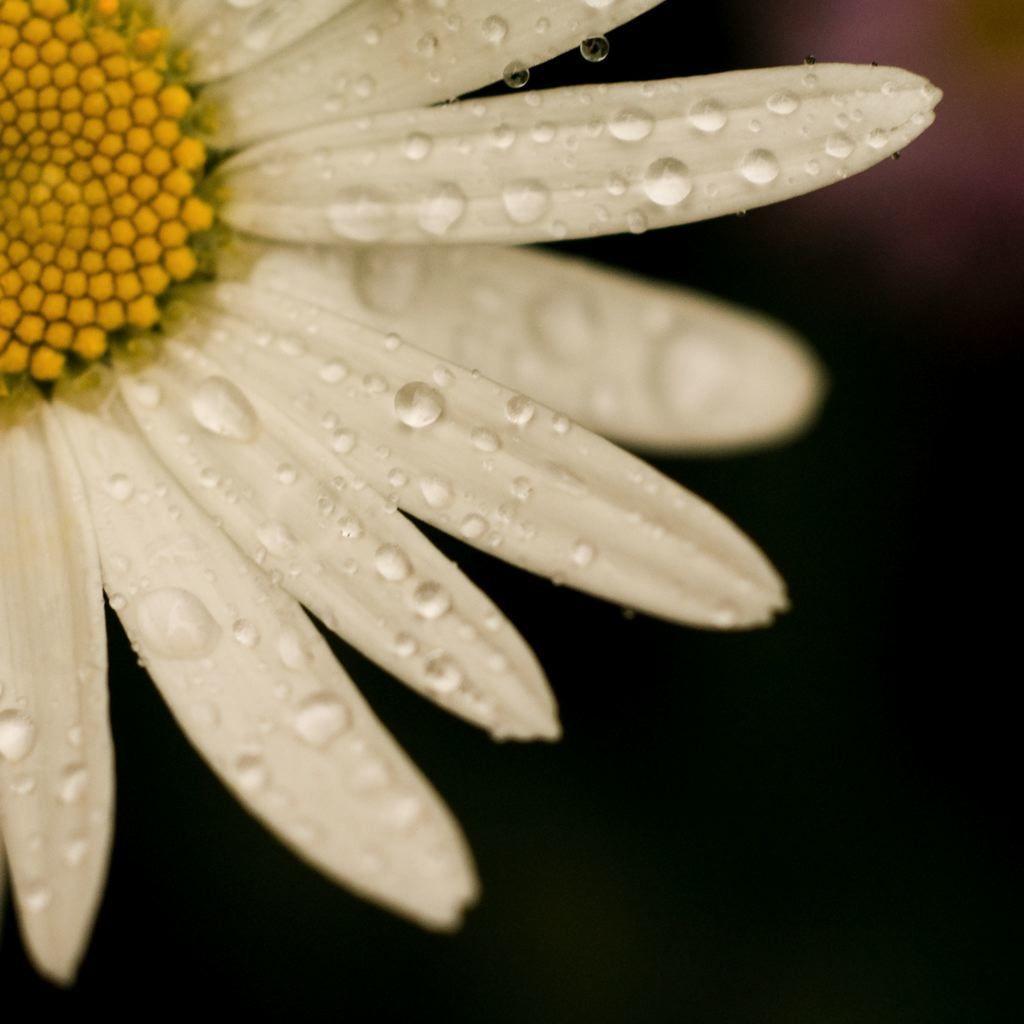How would you summarize this image in a sentence or two? In this picture I can see a flower with water drops on it, and there is blur background. 